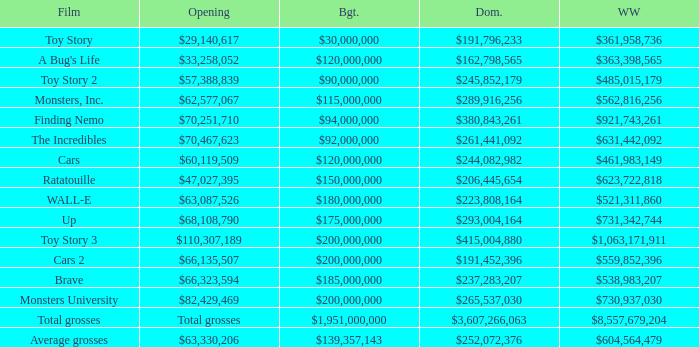WHAT IS THE BUDGET WHEN THE WORLDWIDE BOX OFFICE IS $363,398,565? $120,000,000. 